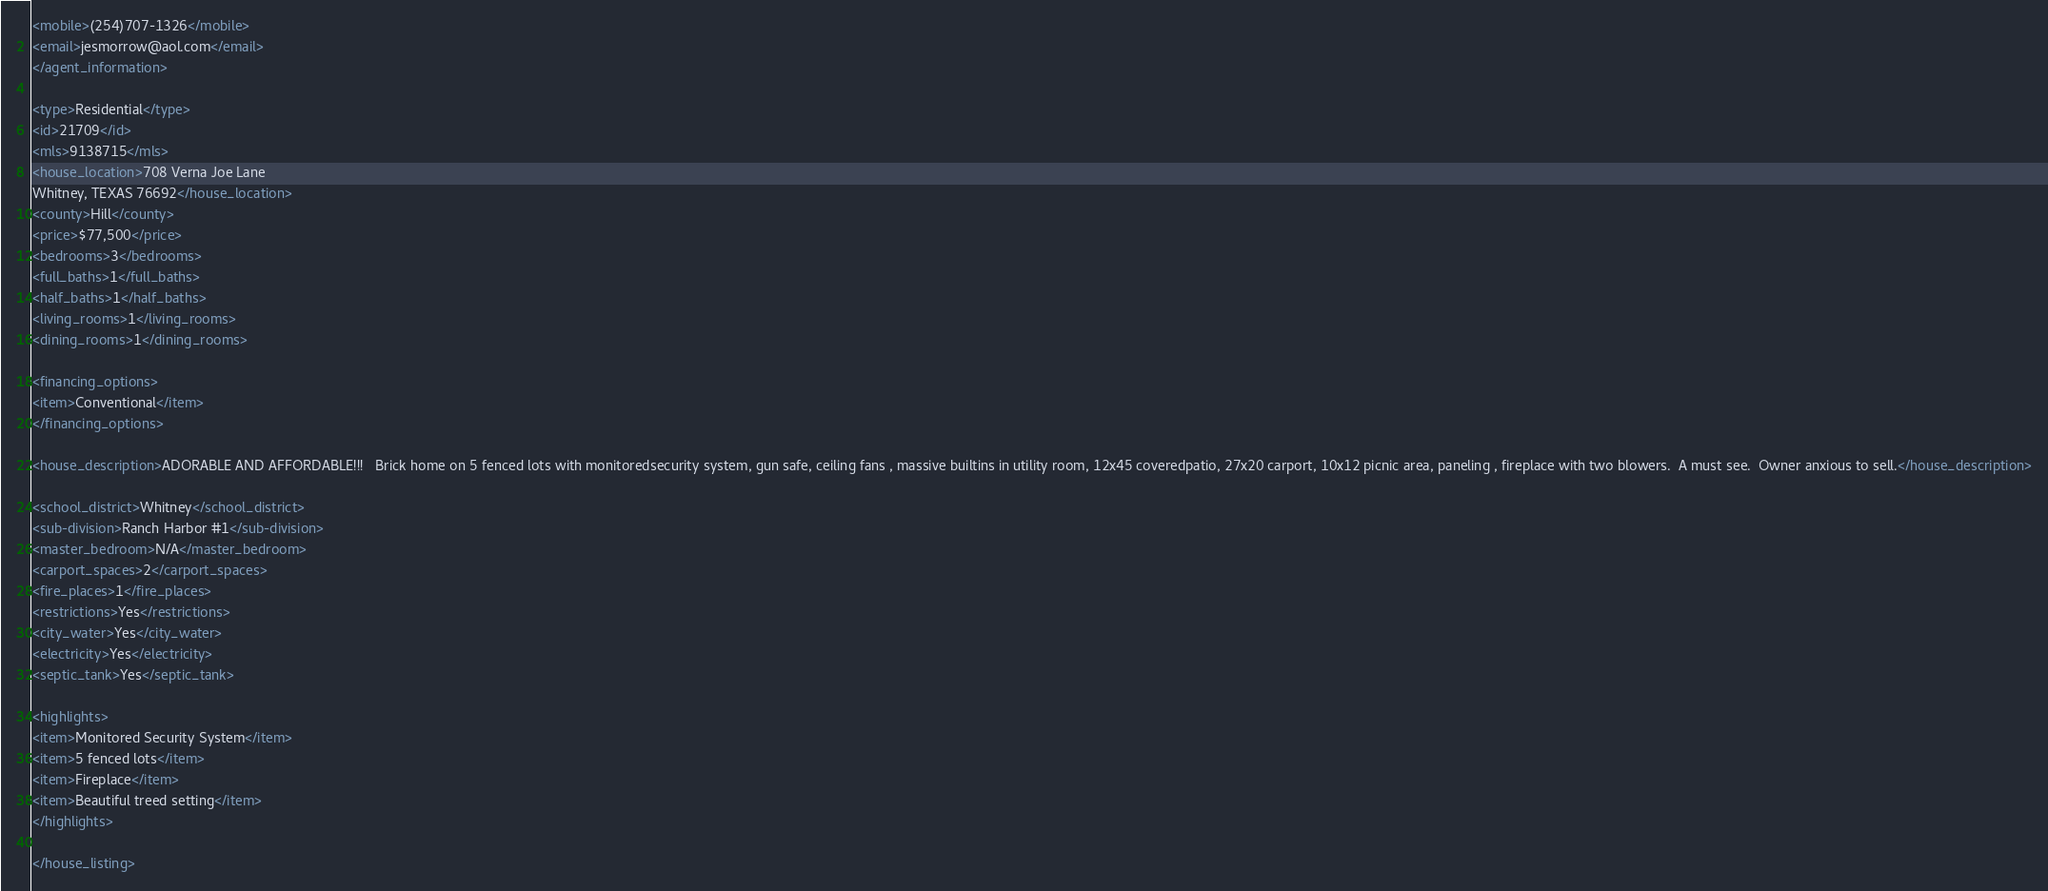Convert code to text. <code><loc_0><loc_0><loc_500><loc_500><_XML_><mobile>(254)707-1326</mobile>
<email>jesmorrow@aol.com</email>
</agent_information>

<type>Residential</type>
<id>21709</id>
<mls>9138715</mls>
<house_location>708 Verna Joe Lane
Whitney, TEXAS 76692</house_location>
<county>Hill</county>
<price>$77,500</price>
<bedrooms>3</bedrooms>
<full_baths>1</full_baths>
<half_baths>1</half_baths>
<living_rooms>1</living_rooms>
<dining_rooms>1</dining_rooms>

<financing_options>
<item>Conventional</item>
</financing_options>

<house_description>ADORABLE AND AFFORDABLE!!!   Brick home on 5 fenced lots with monitoredsecurity system, gun safe, ceiling fans , massive builtins in utility room, 12x45 coveredpatio, 27x20 carport, 10x12 picnic area, paneling , fireplace with two blowers.  A must see.  Owner anxious to sell.</house_description>

<school_district>Whitney</school_district>
<sub-division>Ranch Harbor #1</sub-division>
<master_bedroom>N/A</master_bedroom>
<carport_spaces>2</carport_spaces>
<fire_places>1</fire_places>
<restrictions>Yes</restrictions>
<city_water>Yes</city_water>
<electricity>Yes</electricity>
<septic_tank>Yes</septic_tank>

<highlights>
<item>Monitored Security System</item>
<item>5 fenced lots</item>
<item>Fireplace</item>
<item>Beautiful treed setting</item>
</highlights>

</house_listing>





</code> 